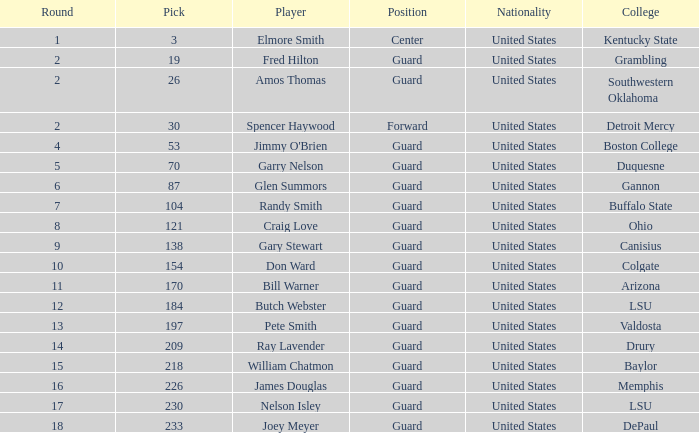WHAT POSITION HAS A ROUND LARGER THAN 2, FOR VALDOSTA COLLEGE? Guard. 